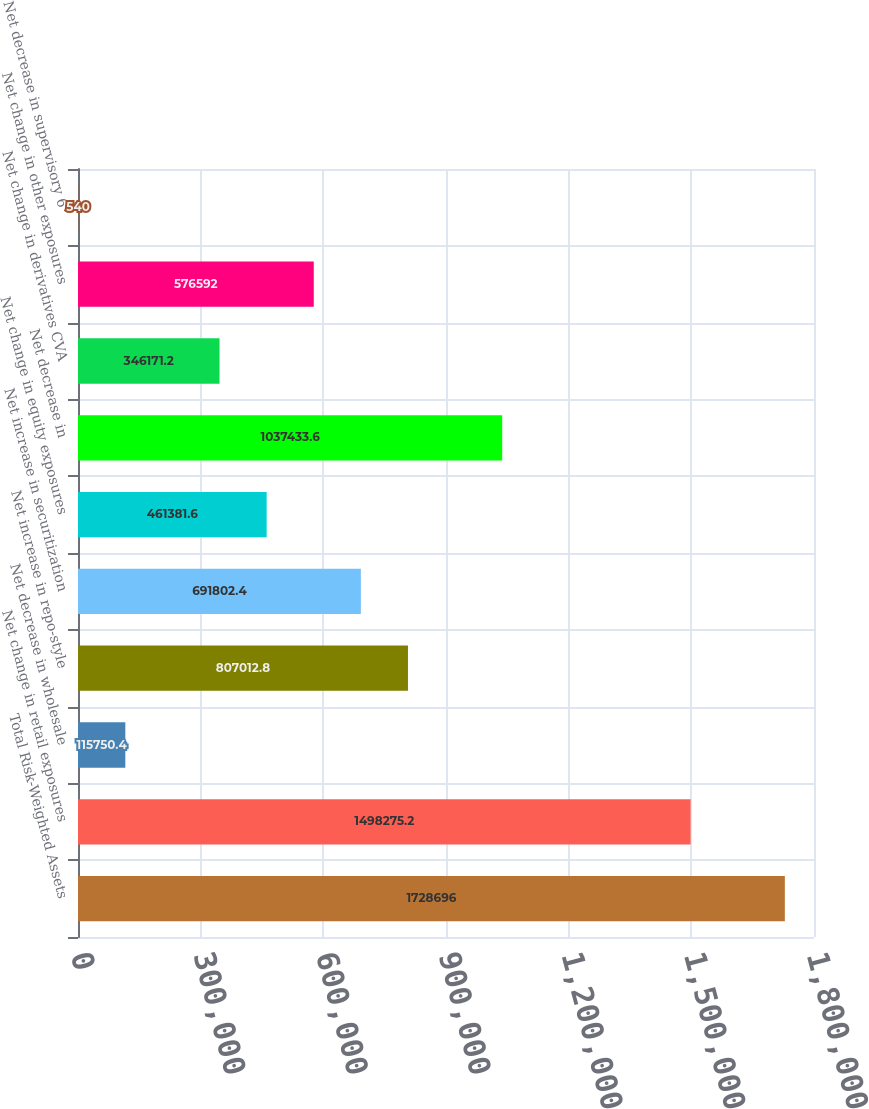Convert chart to OTSL. <chart><loc_0><loc_0><loc_500><loc_500><bar_chart><fcel>Total Risk-Weighted Assets<fcel>Net change in retail exposures<fcel>Net decrease in wholesale<fcel>Net increase in repo-style<fcel>Net increase in securitization<fcel>Net change in equity exposures<fcel>Net decrease in<fcel>Net change in derivatives CVA<fcel>Net change in other exposures<fcel>Net decrease in supervisory 6<nl><fcel>1.7287e+06<fcel>1.49828e+06<fcel>115750<fcel>807013<fcel>691802<fcel>461382<fcel>1.03743e+06<fcel>346171<fcel>576592<fcel>540<nl></chart> 